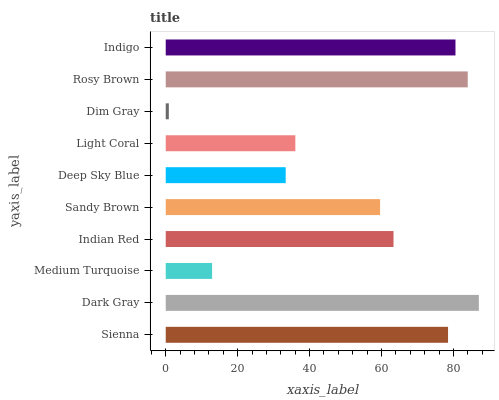Is Dim Gray the minimum?
Answer yes or no. Yes. Is Dark Gray the maximum?
Answer yes or no. Yes. Is Medium Turquoise the minimum?
Answer yes or no. No. Is Medium Turquoise the maximum?
Answer yes or no. No. Is Dark Gray greater than Medium Turquoise?
Answer yes or no. Yes. Is Medium Turquoise less than Dark Gray?
Answer yes or no. Yes. Is Medium Turquoise greater than Dark Gray?
Answer yes or no. No. Is Dark Gray less than Medium Turquoise?
Answer yes or no. No. Is Indian Red the high median?
Answer yes or no. Yes. Is Sandy Brown the low median?
Answer yes or no. Yes. Is Deep Sky Blue the high median?
Answer yes or no. No. Is Deep Sky Blue the low median?
Answer yes or no. No. 